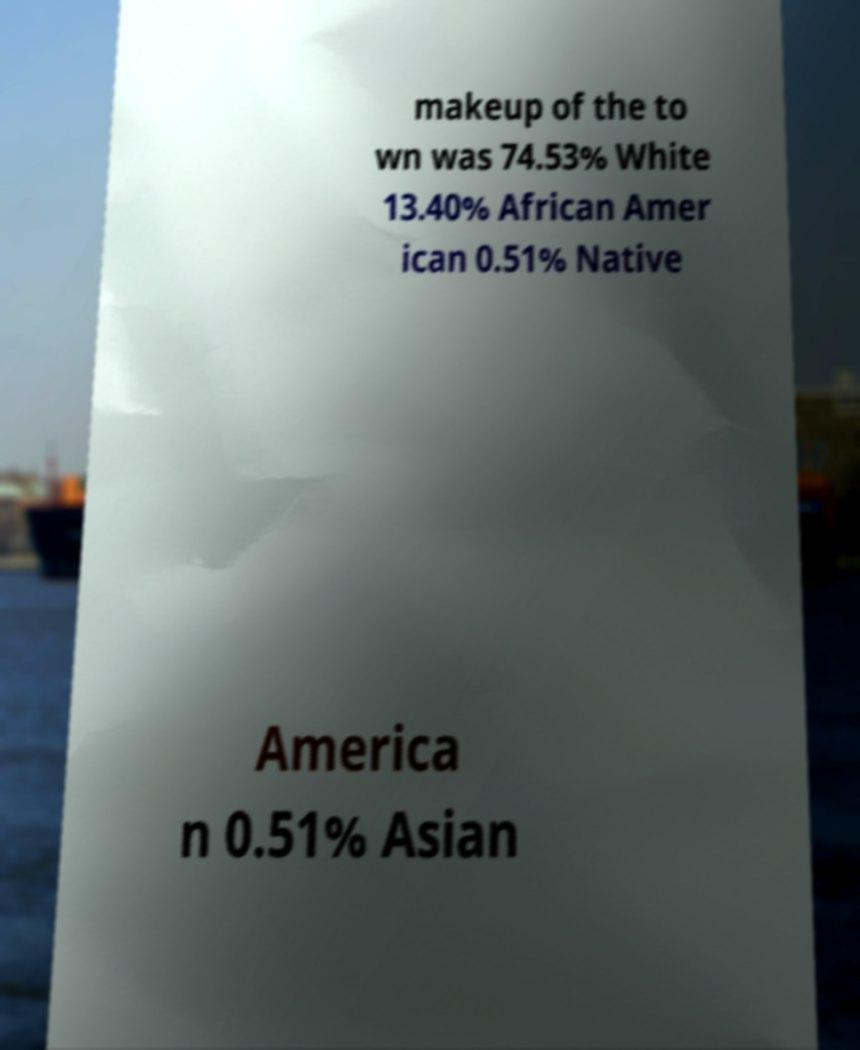What messages or text are displayed in this image? I need them in a readable, typed format. makeup of the to wn was 74.53% White 13.40% African Amer ican 0.51% Native America n 0.51% Asian 